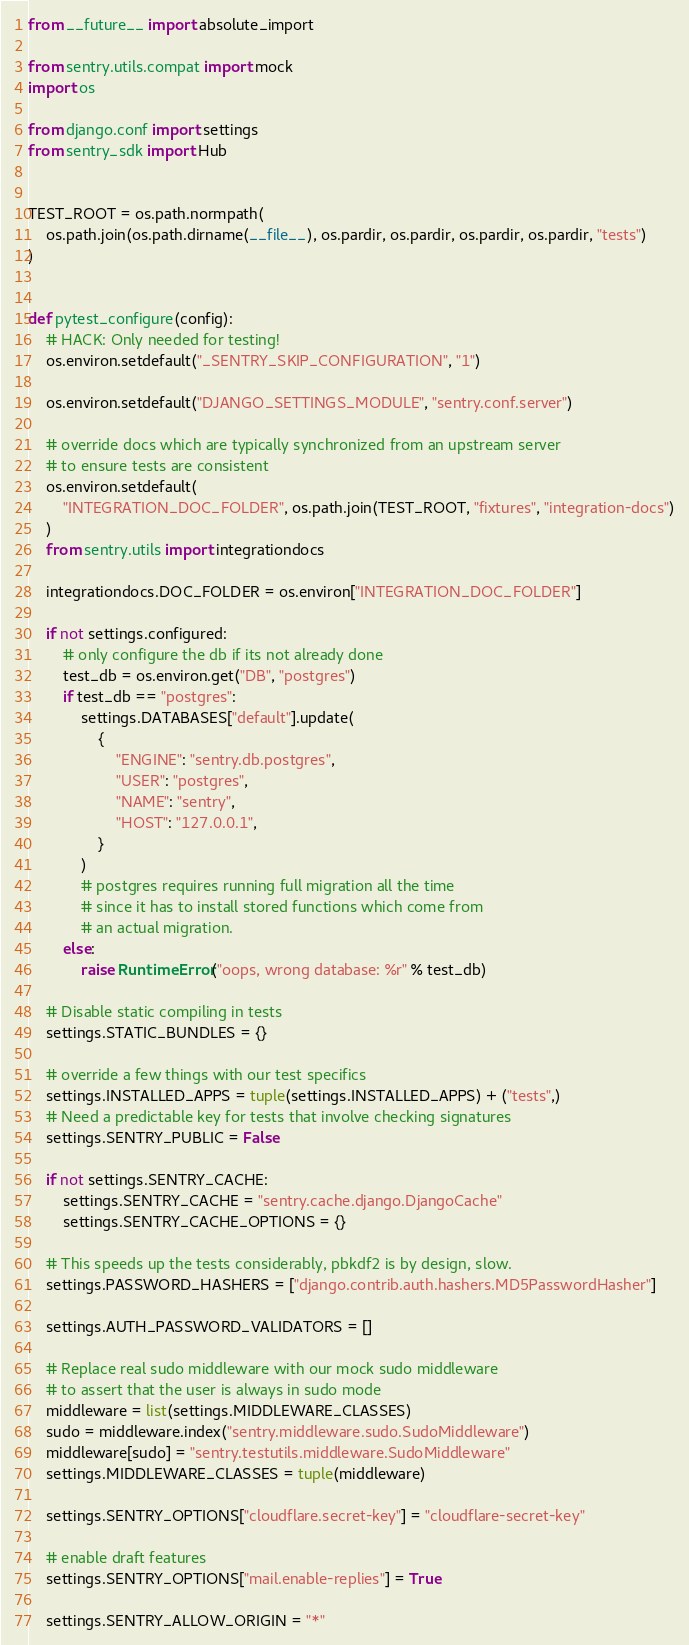Convert code to text. <code><loc_0><loc_0><loc_500><loc_500><_Python_>from __future__ import absolute_import

from sentry.utils.compat import mock
import os

from django.conf import settings
from sentry_sdk import Hub


TEST_ROOT = os.path.normpath(
    os.path.join(os.path.dirname(__file__), os.pardir, os.pardir, os.pardir, os.pardir, "tests")
)


def pytest_configure(config):
    # HACK: Only needed for testing!
    os.environ.setdefault("_SENTRY_SKIP_CONFIGURATION", "1")

    os.environ.setdefault("DJANGO_SETTINGS_MODULE", "sentry.conf.server")

    # override docs which are typically synchronized from an upstream server
    # to ensure tests are consistent
    os.environ.setdefault(
        "INTEGRATION_DOC_FOLDER", os.path.join(TEST_ROOT, "fixtures", "integration-docs")
    )
    from sentry.utils import integrationdocs

    integrationdocs.DOC_FOLDER = os.environ["INTEGRATION_DOC_FOLDER"]

    if not settings.configured:
        # only configure the db if its not already done
        test_db = os.environ.get("DB", "postgres")
        if test_db == "postgres":
            settings.DATABASES["default"].update(
                {
                    "ENGINE": "sentry.db.postgres",
                    "USER": "postgres",
                    "NAME": "sentry",
                    "HOST": "127.0.0.1",
                }
            )
            # postgres requires running full migration all the time
            # since it has to install stored functions which come from
            # an actual migration.
        else:
            raise RuntimeError("oops, wrong database: %r" % test_db)

    # Disable static compiling in tests
    settings.STATIC_BUNDLES = {}

    # override a few things with our test specifics
    settings.INSTALLED_APPS = tuple(settings.INSTALLED_APPS) + ("tests",)
    # Need a predictable key for tests that involve checking signatures
    settings.SENTRY_PUBLIC = False

    if not settings.SENTRY_CACHE:
        settings.SENTRY_CACHE = "sentry.cache.django.DjangoCache"
        settings.SENTRY_CACHE_OPTIONS = {}

    # This speeds up the tests considerably, pbkdf2 is by design, slow.
    settings.PASSWORD_HASHERS = ["django.contrib.auth.hashers.MD5PasswordHasher"]

    settings.AUTH_PASSWORD_VALIDATORS = []

    # Replace real sudo middleware with our mock sudo middleware
    # to assert that the user is always in sudo mode
    middleware = list(settings.MIDDLEWARE_CLASSES)
    sudo = middleware.index("sentry.middleware.sudo.SudoMiddleware")
    middleware[sudo] = "sentry.testutils.middleware.SudoMiddleware"
    settings.MIDDLEWARE_CLASSES = tuple(middleware)

    settings.SENTRY_OPTIONS["cloudflare.secret-key"] = "cloudflare-secret-key"

    # enable draft features
    settings.SENTRY_OPTIONS["mail.enable-replies"] = True

    settings.SENTRY_ALLOW_ORIGIN = "*"
</code> 